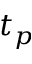<formula> <loc_0><loc_0><loc_500><loc_500>t _ { p }</formula> 